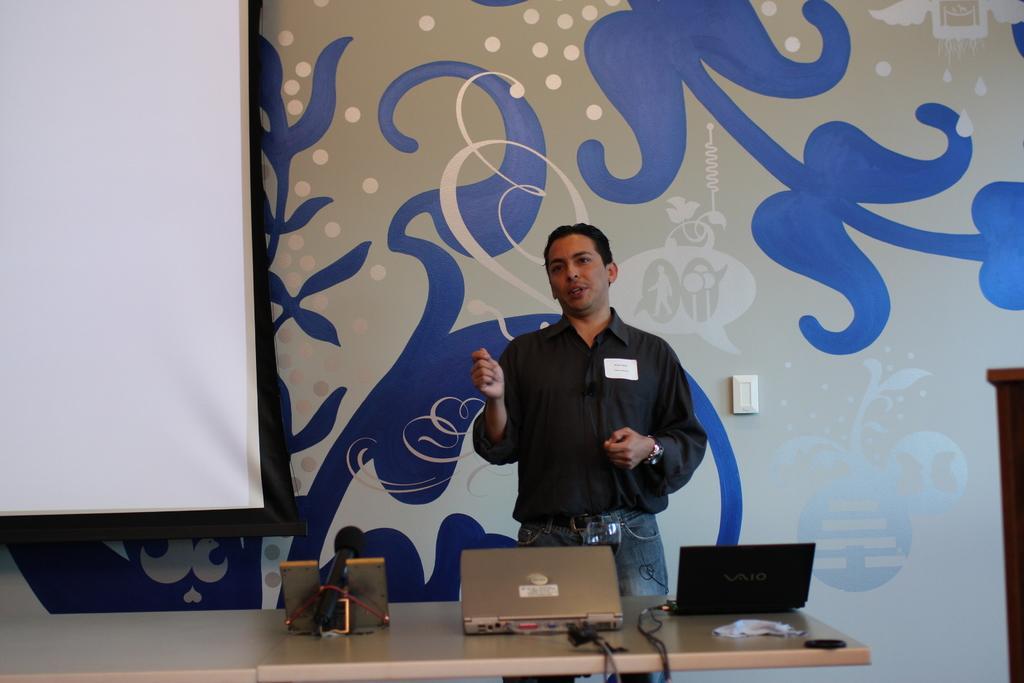Can you describe this image briefly? In this image we can see a man is standing. He is wearing a black color shirt with jeans. In front of the man, table is present. On the table, we can see laptops, wires and one object. In the background, there is a switchboard attached to the wall and one big screen is present. 